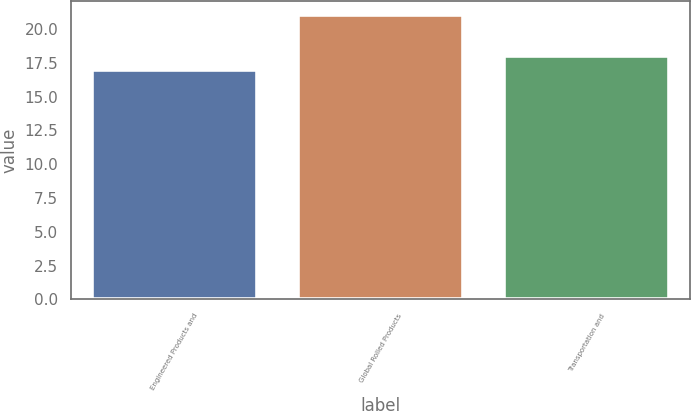Convert chart to OTSL. <chart><loc_0><loc_0><loc_500><loc_500><bar_chart><fcel>Engineered Products and<fcel>Global Rolled Products<fcel>Transportation and<nl><fcel>17<fcel>21<fcel>18<nl></chart> 